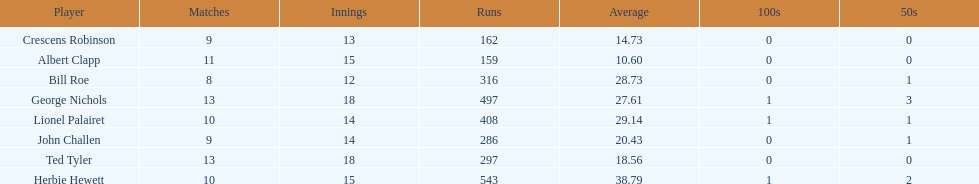What were the number of innings albert clapp had? 15. 